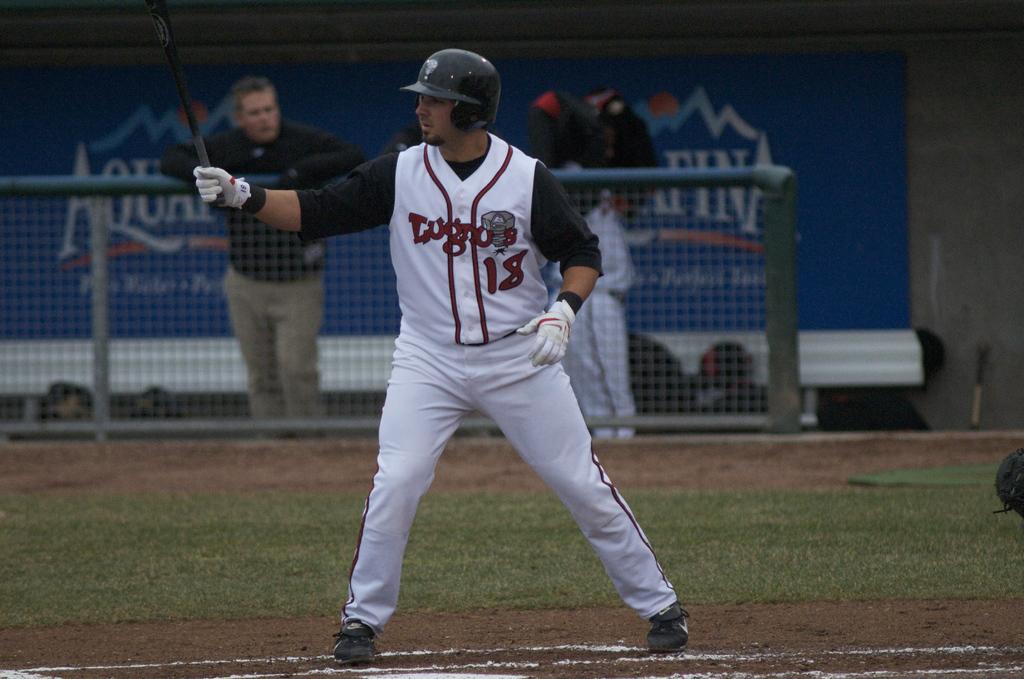What team does he play for?
Your answer should be compact. Lugnuts. What is his jersey number?
Make the answer very short. 18. 